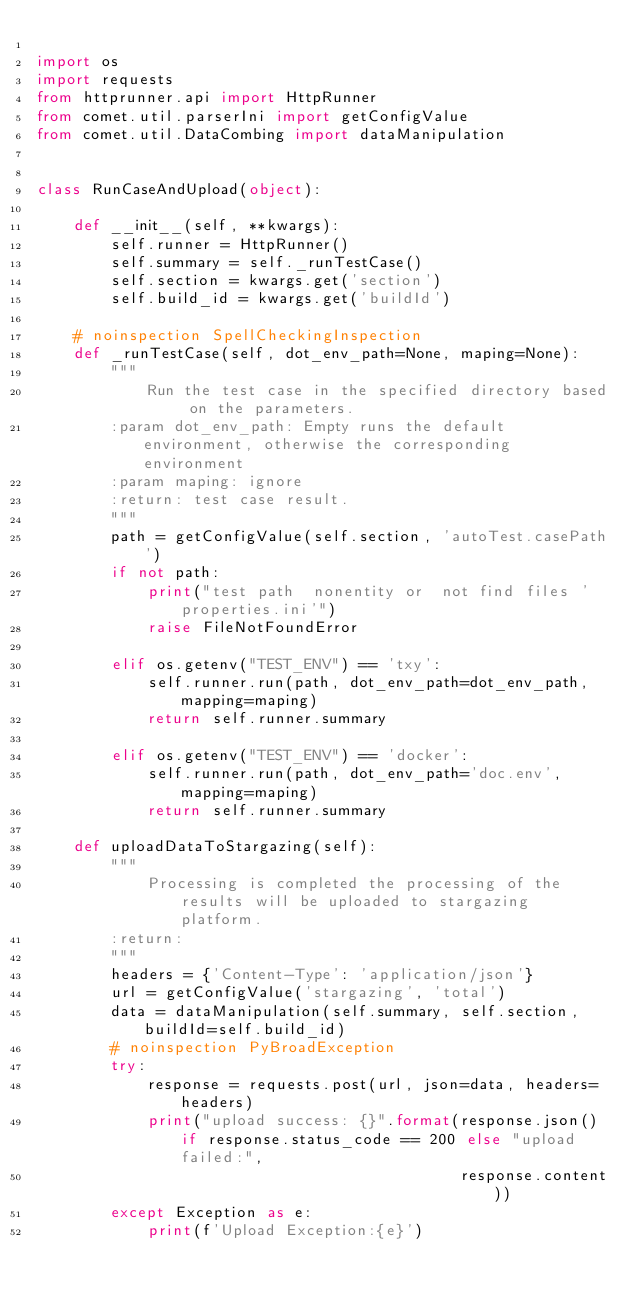Convert code to text. <code><loc_0><loc_0><loc_500><loc_500><_Python_>
import os
import requests
from httprunner.api import HttpRunner
from comet.util.parserIni import getConfigValue
from comet.util.DataCombing import dataManipulation


class RunCaseAndUpload(object):

    def __init__(self, **kwargs):
        self.runner = HttpRunner()
        self.summary = self._runTestCase()
        self.section = kwargs.get('section')
        self.build_id = kwargs.get('buildId')

    # noinspection SpellCheckingInspection
    def _runTestCase(self, dot_env_path=None, maping=None):
        """
            Run the test case in the specified directory based on the parameters.
        :param dot_env_path: Empty runs the default environment, otherwise the corresponding environment
        :param maping: ignore
        :return: test case result.
        """
        path = getConfigValue(self.section, 'autoTest.casePath')
        if not path:
            print("test path  nonentity or  not find files 'properties.ini'")
            raise FileNotFoundError

        elif os.getenv("TEST_ENV") == 'txy':
            self.runner.run(path, dot_env_path=dot_env_path, mapping=maping)
            return self.runner.summary

        elif os.getenv("TEST_ENV") == 'docker':
            self.runner.run(path, dot_env_path='doc.env', mapping=maping)
            return self.runner.summary

    def uploadDataToStargazing(self):
        """
            Processing is completed the processing of the results will be uploaded to stargazing platform.
        :return:
        """
        headers = {'Content-Type': 'application/json'}
        url = getConfigValue('stargazing', 'total')
        data = dataManipulation(self.summary, self.section, buildId=self.build_id)
        # noinspection PyBroadException
        try:
            response = requests.post(url, json=data, headers=headers)
            print("upload success: {}".format(response.json() if response.status_code == 200 else "upload failed:",
                                              response.content))
        except Exception as e:
            print(f'Upload Exception:{e}')
</code> 